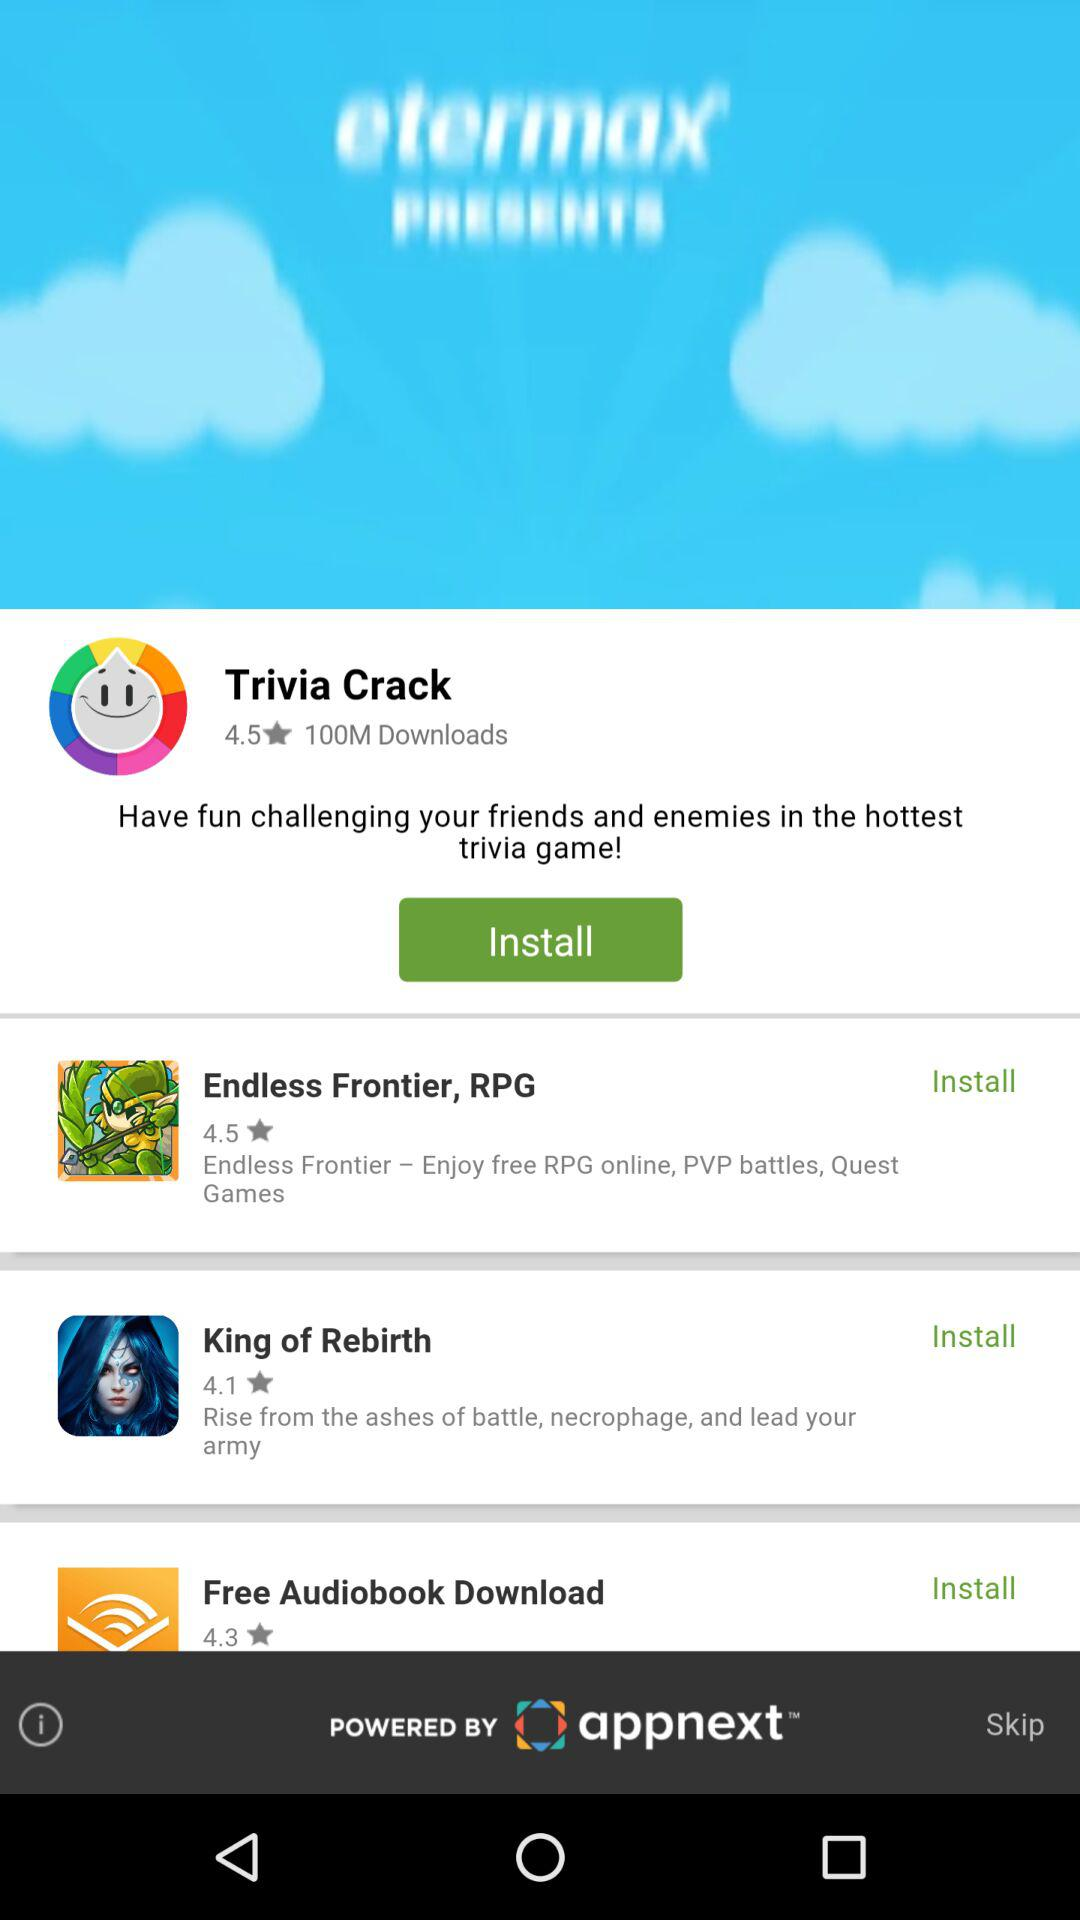How many apps have a rating of 4.5 or higher?
Answer the question using a single word or phrase. 2 